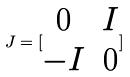Convert formula to latex. <formula><loc_0><loc_0><loc_500><loc_500>J = [ \begin{matrix} 0 & I \\ - I & 0 \end{matrix} ]</formula> 